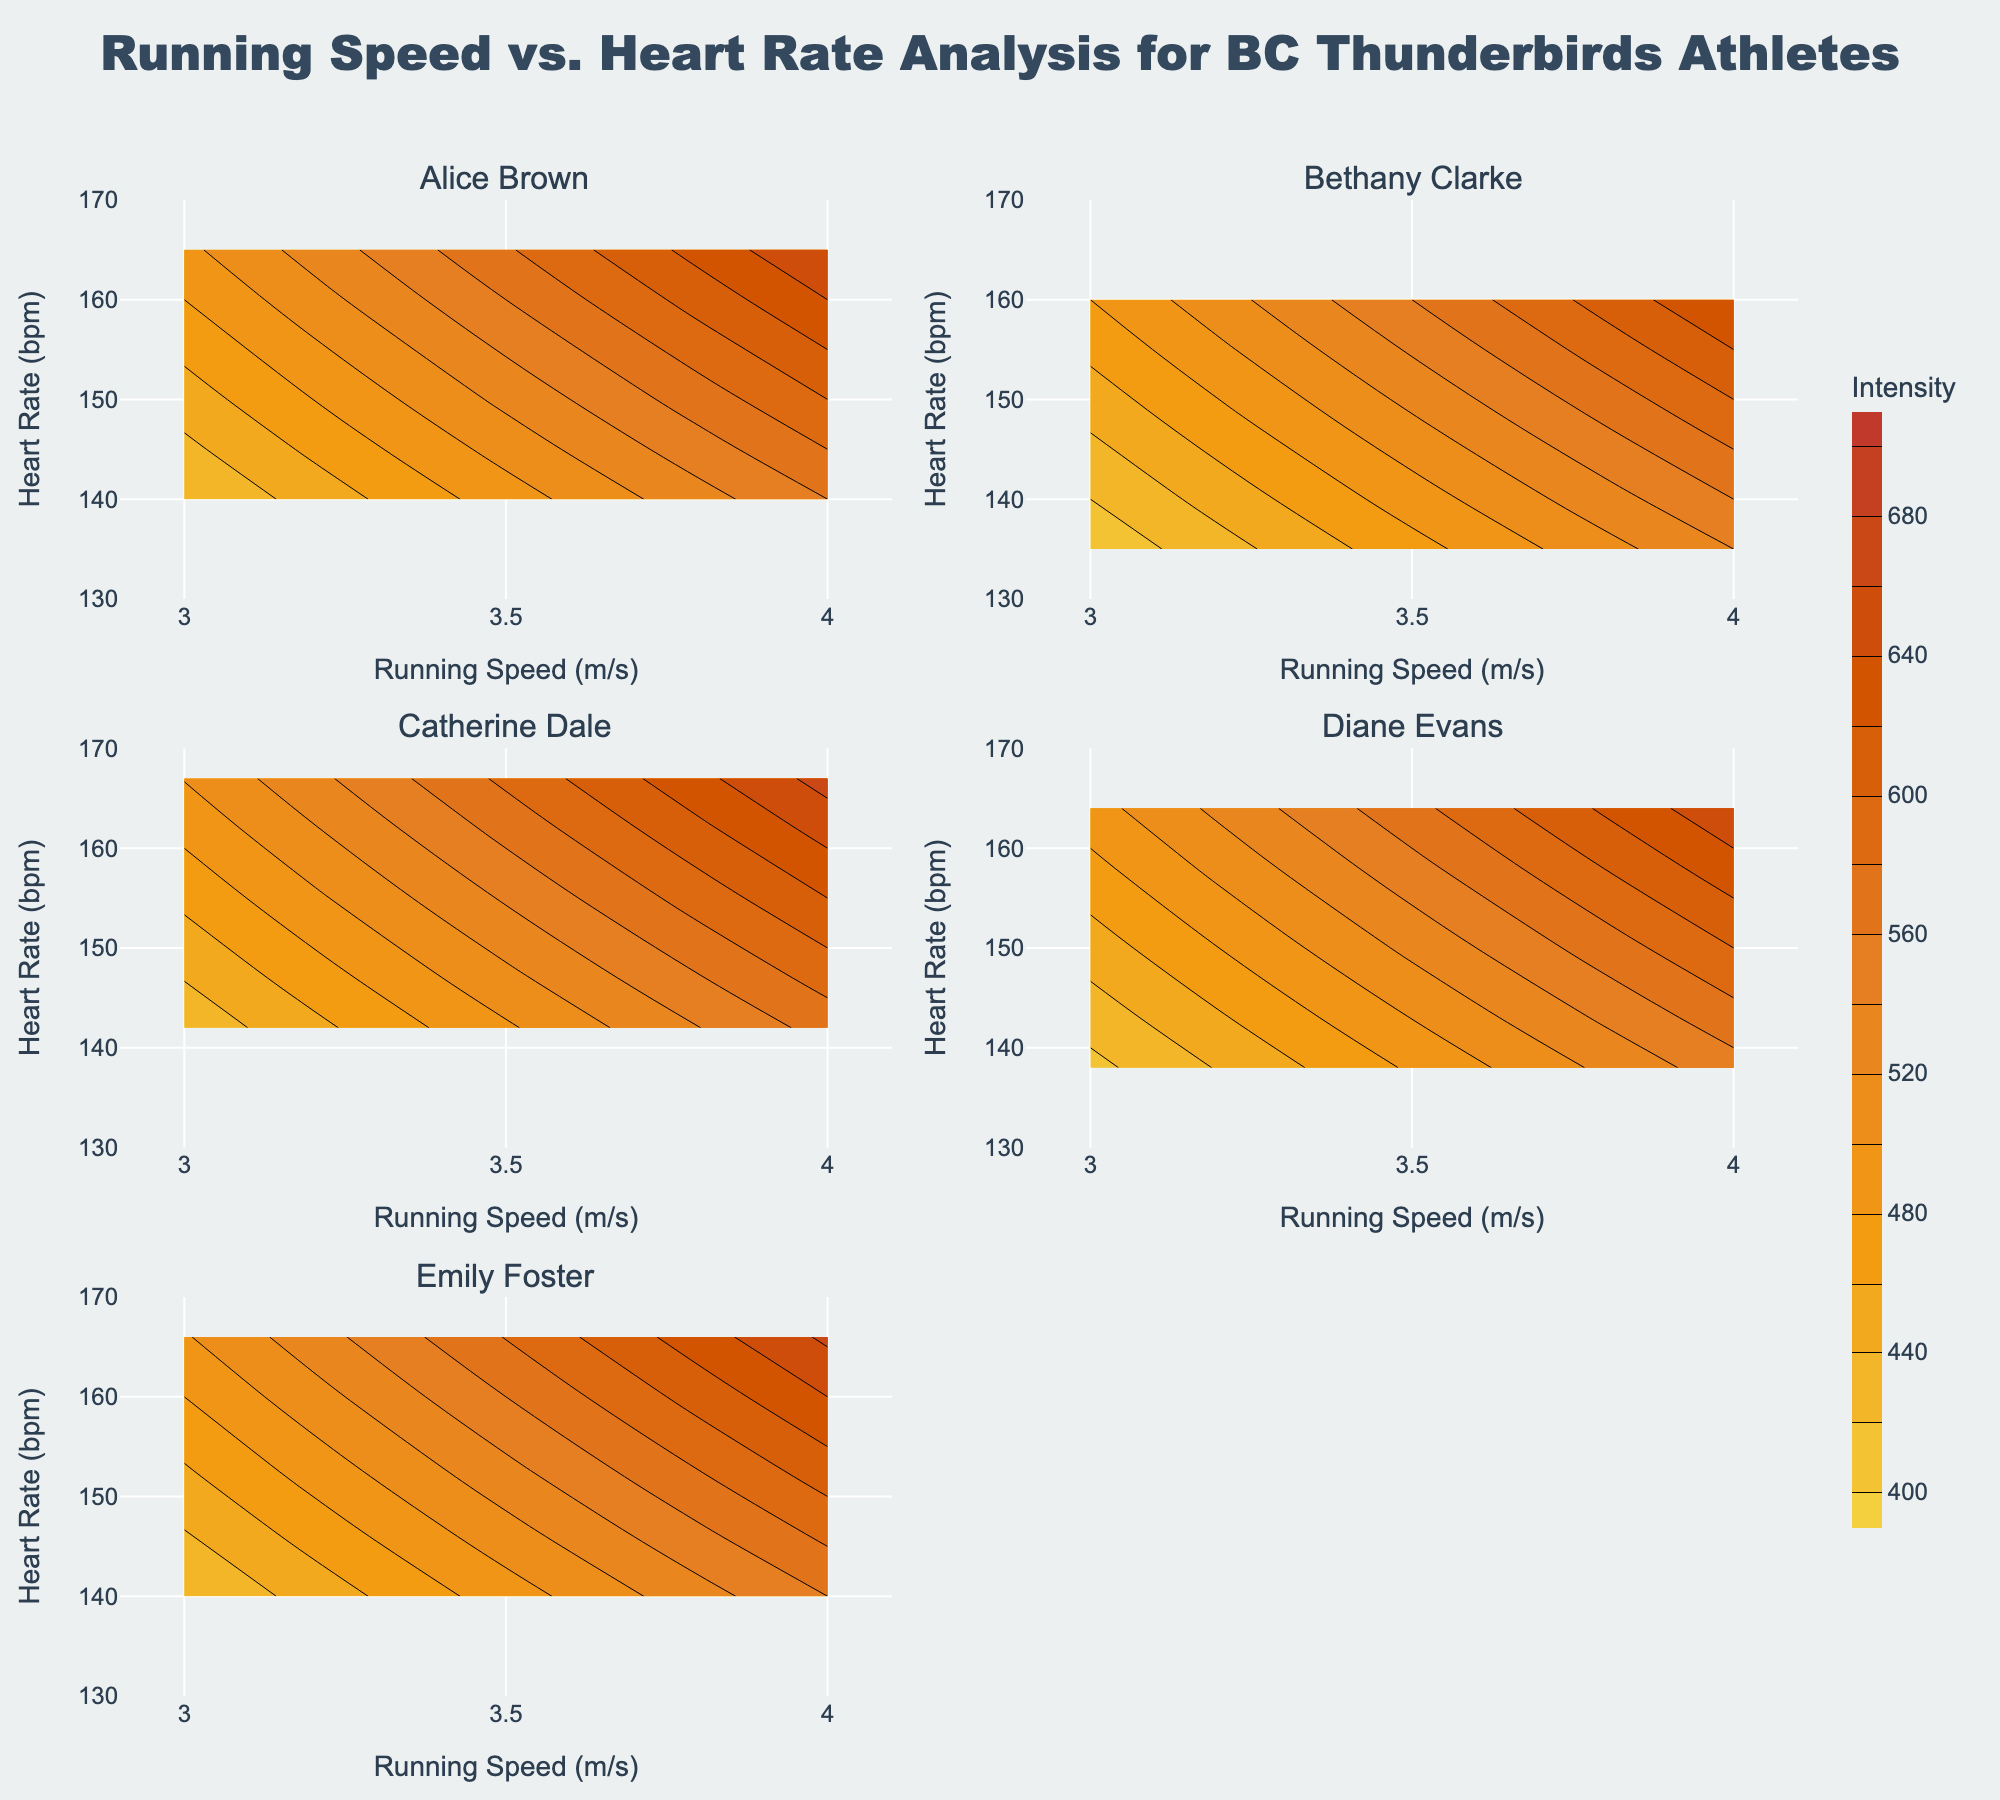What is the title of the figure? The title is usually located at the top of the figure. Based on its position, size, and font, it reads "Running Speed vs. Heart Rate Analysis for BC Thunderbirds Athletes".
Answer: Running Speed vs. Heart Rate Analysis for BC Thunderbirds Athletes How many athletes are analyzed in the figure? The subplot titles correspond to the number of athletes. There are six subplot titles in total, indicating six athletes.
Answer: Six What is the range of the Running Speed axis? By examining the x-axis for any subplot, the range is given from 2.9 to 4.1 m/s.
Answer: 2.9 to 4.1 m/s Which athlete has a subplot in the second row and first column? By referring to the ordinal position of the athletes and mapping it to the subplot arrangement, Diane Evans is in the second row and first column.
Answer: Diane Evans At what Running Speed and Heart Rate does Catherine Dale's contour start in her subplot? The contours start from the smallest contour line values; for Catherine Dale, the Running Speed (x-axis) is 3.0 m/s and Heart Rate (y-axis) is 142 bpm.
Answer: 3.0 m/s and 142 bpm Which subplot shows the highest intensity values? Intensity is indicated by the z-values in the contours. Upon examining the colors, the subplot with Emily Foster shows the highest intensity values as it aligns with the highest end of the color scale.
Answer: Emily Foster Is the Heart Rate of Alice Brown or Diane Evans higher at a Running Speed of 3.8 m/s? Alice Brown's Heart Rate at 3.8 m/s is 160 bpm; Diane Evans' Heart Rate at the same speed is 158 bpm. Hence, Alice Brown has a higher Heart Rate at 3.8 m/s.
Answer: Alice Brown What is the average Heart Rate at a Running Speed of 3.0 m/s across all athletes? Adding the Heart Rates of all athletes at 3.0 m/s (140, 135, 142, 138, 140) and dividing by the number of athletes: (140 + 135 + 142 + 138 + 140) / 5 = 695 / 5.
Answer: 139 bpm Which athlete has the smallest change in Heart Rate from 3.0 to 4.0 m/s? Calculate the change for each:  
- Alice Brown: 165-140=25  
- Bethany Clarke: 160-135=25  
- Catherine Dale: 167-142=25  
- Diane Evans: 164-138=26  
- Emily Foster: 166-140=26  
Both Alice Brown, Bethany Clarke, and Catherine Dale have the smallest change, which is 25 bpm.
Answer: Alice Brown, Bethany Clarke, Catherine Dale 